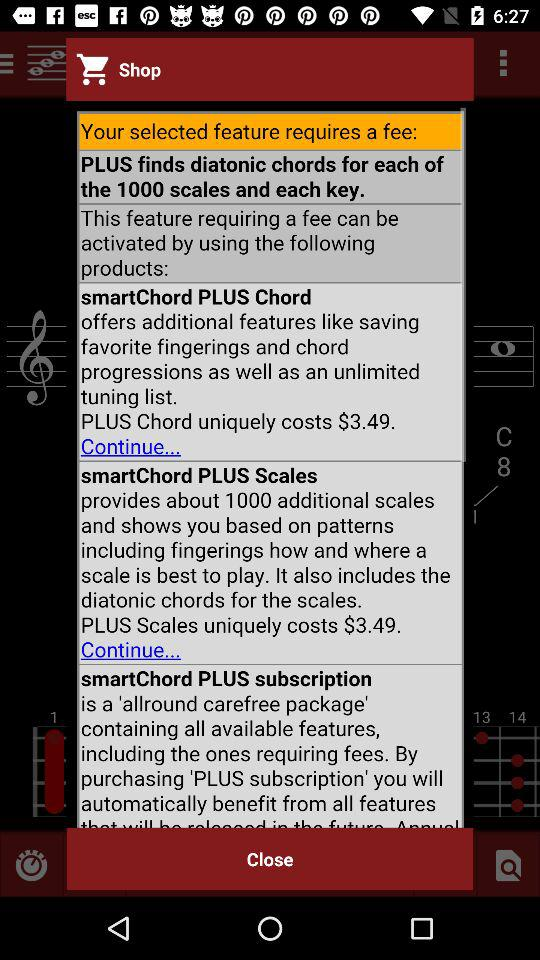How many products are available to activate the feature requiring a fee?
Answer the question using a single word or phrase. 3 